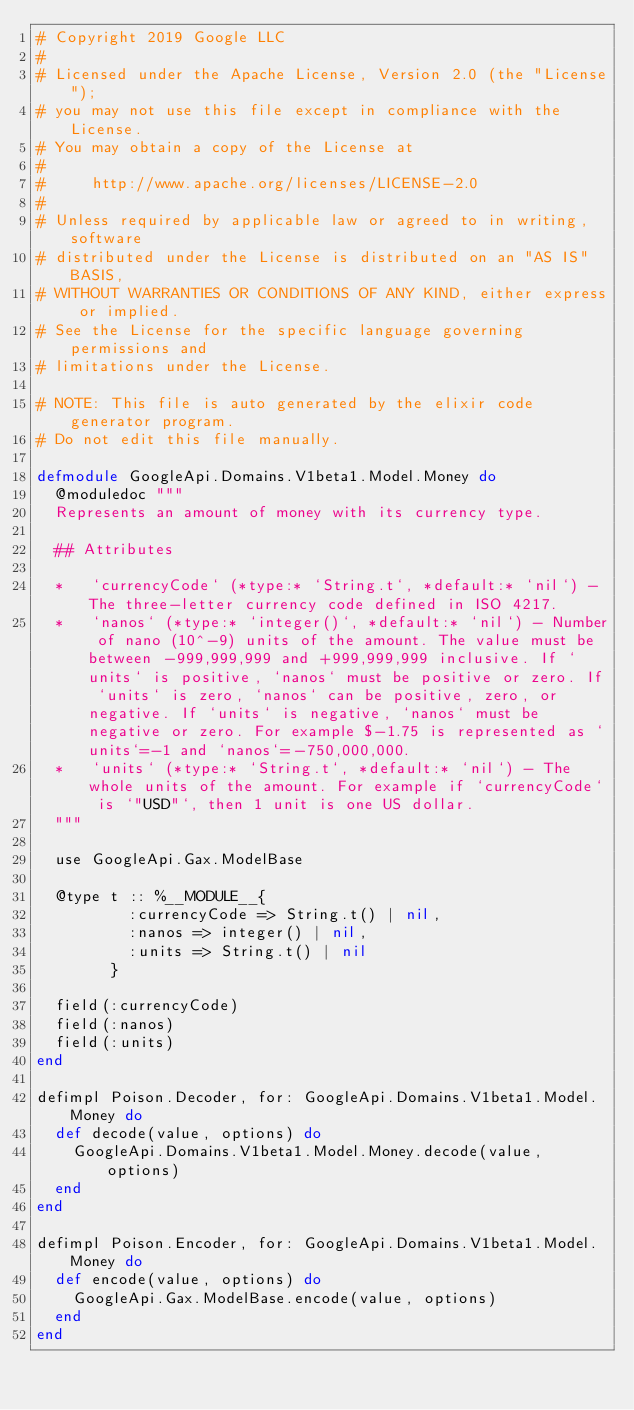<code> <loc_0><loc_0><loc_500><loc_500><_Elixir_># Copyright 2019 Google LLC
#
# Licensed under the Apache License, Version 2.0 (the "License");
# you may not use this file except in compliance with the License.
# You may obtain a copy of the License at
#
#     http://www.apache.org/licenses/LICENSE-2.0
#
# Unless required by applicable law or agreed to in writing, software
# distributed under the License is distributed on an "AS IS" BASIS,
# WITHOUT WARRANTIES OR CONDITIONS OF ANY KIND, either express or implied.
# See the License for the specific language governing permissions and
# limitations under the License.

# NOTE: This file is auto generated by the elixir code generator program.
# Do not edit this file manually.

defmodule GoogleApi.Domains.V1beta1.Model.Money do
  @moduledoc """
  Represents an amount of money with its currency type.

  ## Attributes

  *   `currencyCode` (*type:* `String.t`, *default:* `nil`) - The three-letter currency code defined in ISO 4217.
  *   `nanos` (*type:* `integer()`, *default:* `nil`) - Number of nano (10^-9) units of the amount. The value must be between -999,999,999 and +999,999,999 inclusive. If `units` is positive, `nanos` must be positive or zero. If `units` is zero, `nanos` can be positive, zero, or negative. If `units` is negative, `nanos` must be negative or zero. For example $-1.75 is represented as `units`=-1 and `nanos`=-750,000,000.
  *   `units` (*type:* `String.t`, *default:* `nil`) - The whole units of the amount. For example if `currencyCode` is `"USD"`, then 1 unit is one US dollar.
  """

  use GoogleApi.Gax.ModelBase

  @type t :: %__MODULE__{
          :currencyCode => String.t() | nil,
          :nanos => integer() | nil,
          :units => String.t() | nil
        }

  field(:currencyCode)
  field(:nanos)
  field(:units)
end

defimpl Poison.Decoder, for: GoogleApi.Domains.V1beta1.Model.Money do
  def decode(value, options) do
    GoogleApi.Domains.V1beta1.Model.Money.decode(value, options)
  end
end

defimpl Poison.Encoder, for: GoogleApi.Domains.V1beta1.Model.Money do
  def encode(value, options) do
    GoogleApi.Gax.ModelBase.encode(value, options)
  end
end
</code> 